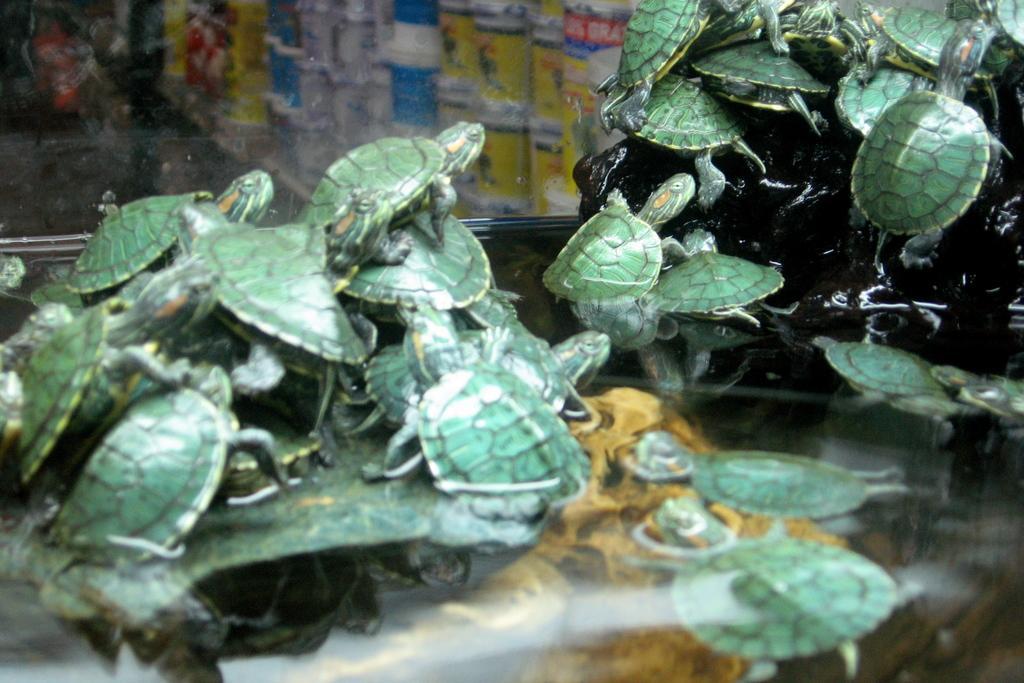In one or two sentences, can you explain what this image depicts? In this image we can see many turtles on the stones. Here we can see water inside the glass box through which we can see some tins. 